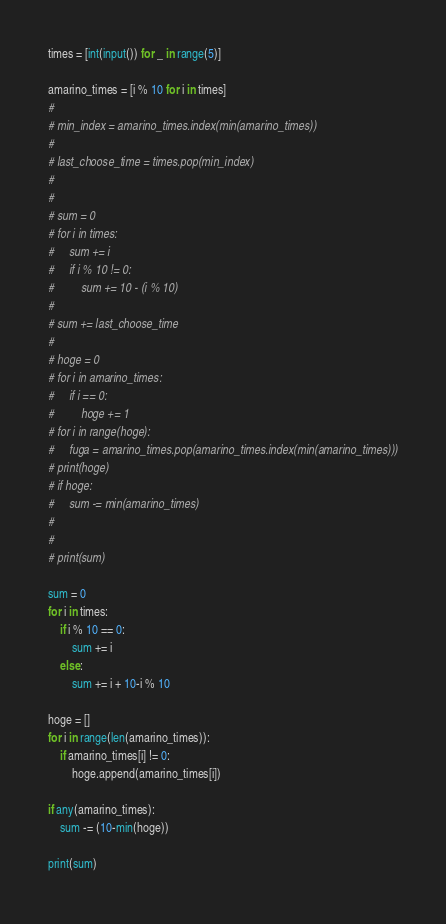<code> <loc_0><loc_0><loc_500><loc_500><_Python_>times = [int(input()) for _ in range(5)]

amarino_times = [i % 10 for i in times]
#
# min_index = amarino_times.index(min(amarino_times))
#
# last_choose_time = times.pop(min_index)
#
#
# sum = 0
# for i in times:
#     sum += i
#     if i % 10 != 0:
#         sum += 10 - (i % 10)
#
# sum += last_choose_time
#
# hoge = 0
# for i in amarino_times:
#     if i == 0:
#         hoge += 1
# for i in range(hoge):
#     fuga = amarino_times.pop(amarino_times.index(min(amarino_times)))
# print(hoge)
# if hoge:
#     sum -= min(amarino_times)
#
#
# print(sum)

sum = 0
for i in times:
    if i % 10 == 0:
        sum += i
    else:
        sum += i + 10-i % 10

hoge = []
for i in range(len(amarino_times)):
    if amarino_times[i] != 0:
        hoge.append(amarino_times[i])

if any(amarino_times):
    sum -= (10-min(hoge))

print(sum)
</code> 